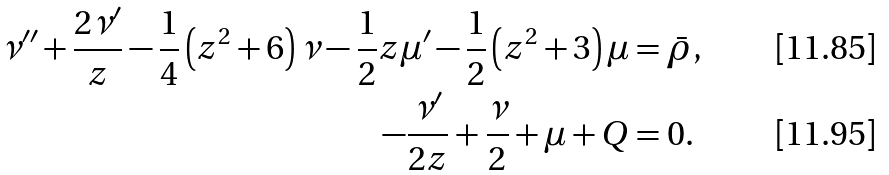<formula> <loc_0><loc_0><loc_500><loc_500>\nu ^ { \prime \prime } + \frac { 2 \nu ^ { \prime } } { z } - \frac { 1 } { 4 } \left ( z ^ { 2 } + 6 \right ) \nu - \frac { 1 } { 2 } z \mu ^ { \prime } - \frac { 1 } { 2 } \left ( z ^ { 2 } + 3 \right ) \mu & = \bar { \rho } , \\ - \frac { \nu ^ { \prime } } { 2 z } + \frac { \nu } { 2 } + \mu + Q & = 0 .</formula> 